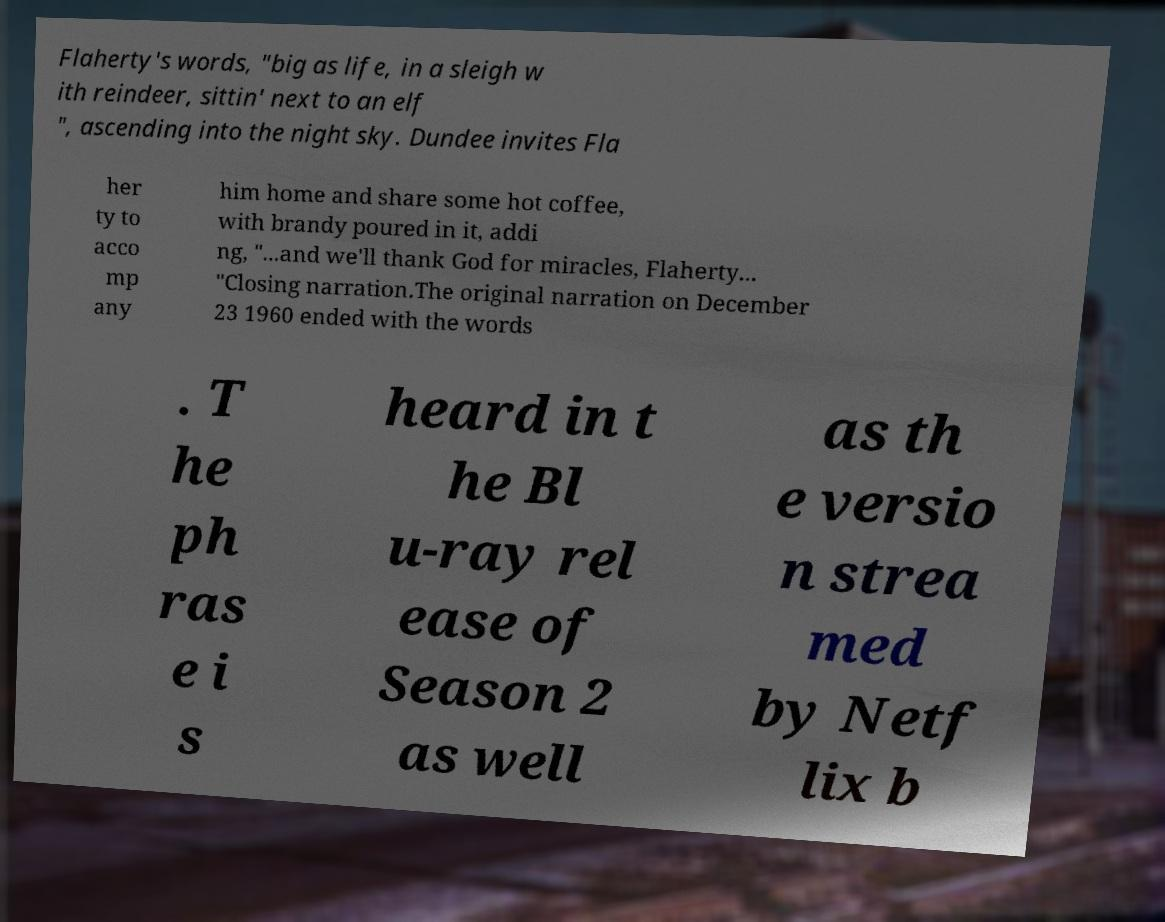Could you extract and type out the text from this image? Flaherty's words, "big as life, in a sleigh w ith reindeer, sittin' next to an elf ", ascending into the night sky. Dundee invites Fla her ty to acco mp any him home and share some hot coffee, with brandy poured in it, addi ng, "...and we'll thank God for miracles, Flaherty... "Closing narration.The original narration on December 23 1960 ended with the words . T he ph ras e i s heard in t he Bl u-ray rel ease of Season 2 as well as th e versio n strea med by Netf lix b 